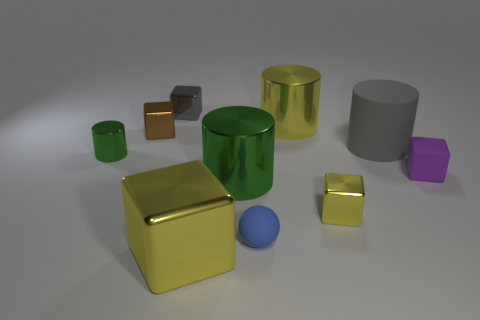What number of other things are the same size as the matte sphere?
Offer a very short reply. 5. What size is the cylinder that is behind the tiny purple matte block and left of the yellow shiny cylinder?
Offer a terse response. Small. There is a rubber sphere; is its color the same as the shiny object that is left of the small brown block?
Your answer should be very brief. No. Is there a big cyan shiny thing that has the same shape as the blue rubber object?
Your response must be concise. No. What number of objects are either red rubber balls or blocks that are on the left side of the sphere?
Offer a terse response. 3. How many other things are there of the same material as the blue thing?
Offer a very short reply. 2. What number of objects are either tiny gray metallic objects or brown blocks?
Ensure brevity in your answer.  2. Are there more cylinders on the left side of the big cube than tiny gray shiny cubes behind the gray metallic object?
Your answer should be very brief. Yes. There is a matte ball in front of the tiny gray metallic cube; does it have the same color as the cylinder that is on the left side of the big shiny cube?
Make the answer very short. No. How big is the sphere in front of the big metal cylinder that is behind the green cylinder that is behind the small matte cube?
Your answer should be compact. Small. 